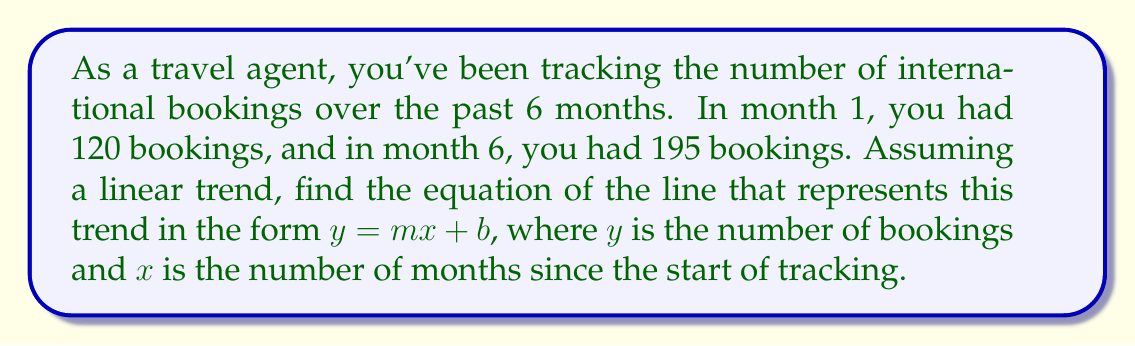Help me with this question. 1. Identify the two points:
   $(x_1, y_1) = (1, 120)$ and $(x_2, y_2) = (6, 195)$

2. Calculate the slope $(m)$ using the point-slope formula:
   $$m = \frac{y_2 - y_1}{x_2 - x_1} = \frac{195 - 120}{6 - 1} = \frac{75}{5} = 15$$

3. Use the point-slope form of a line with the first point $(1, 120)$:
   $$y - y_1 = m(x - x_1)$$
   $$y - 120 = 15(x - 1)$$

4. Distribute the 15:
   $$y - 120 = 15x - 15$$

5. Add 120 to both sides to isolate $y$:
   $$y = 15x - 15 + 120$$

6. Simplify:
   $$y = 15x + 105$$

This equation represents the linear trend in travel bookings over time, where $y$ is the number of bookings and $x$ is the number of months since the start of tracking.
Answer: $y = 15x + 105$ 